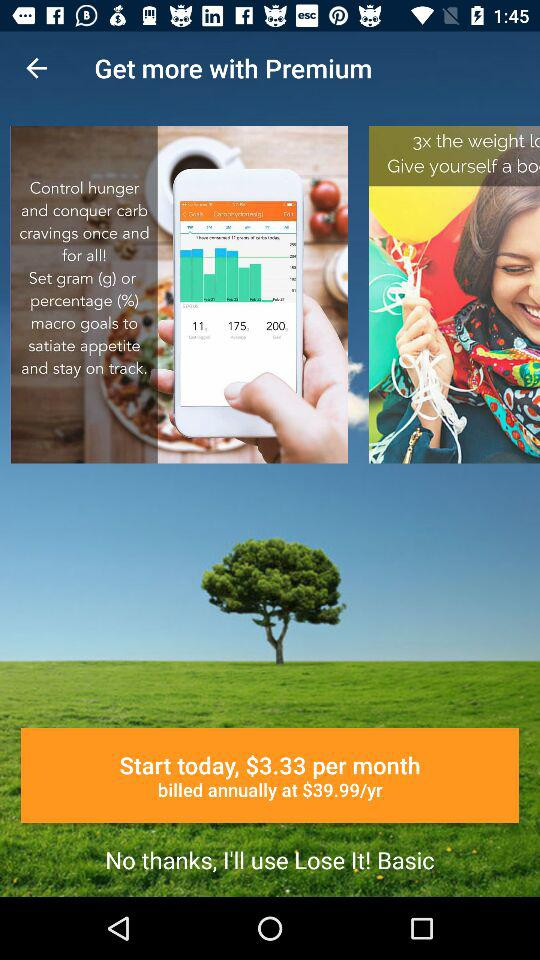How many more dollars are in the cost of the annual subscription than in the cost of the monthly subscription?
Answer the question using a single word or phrase. 36.66 